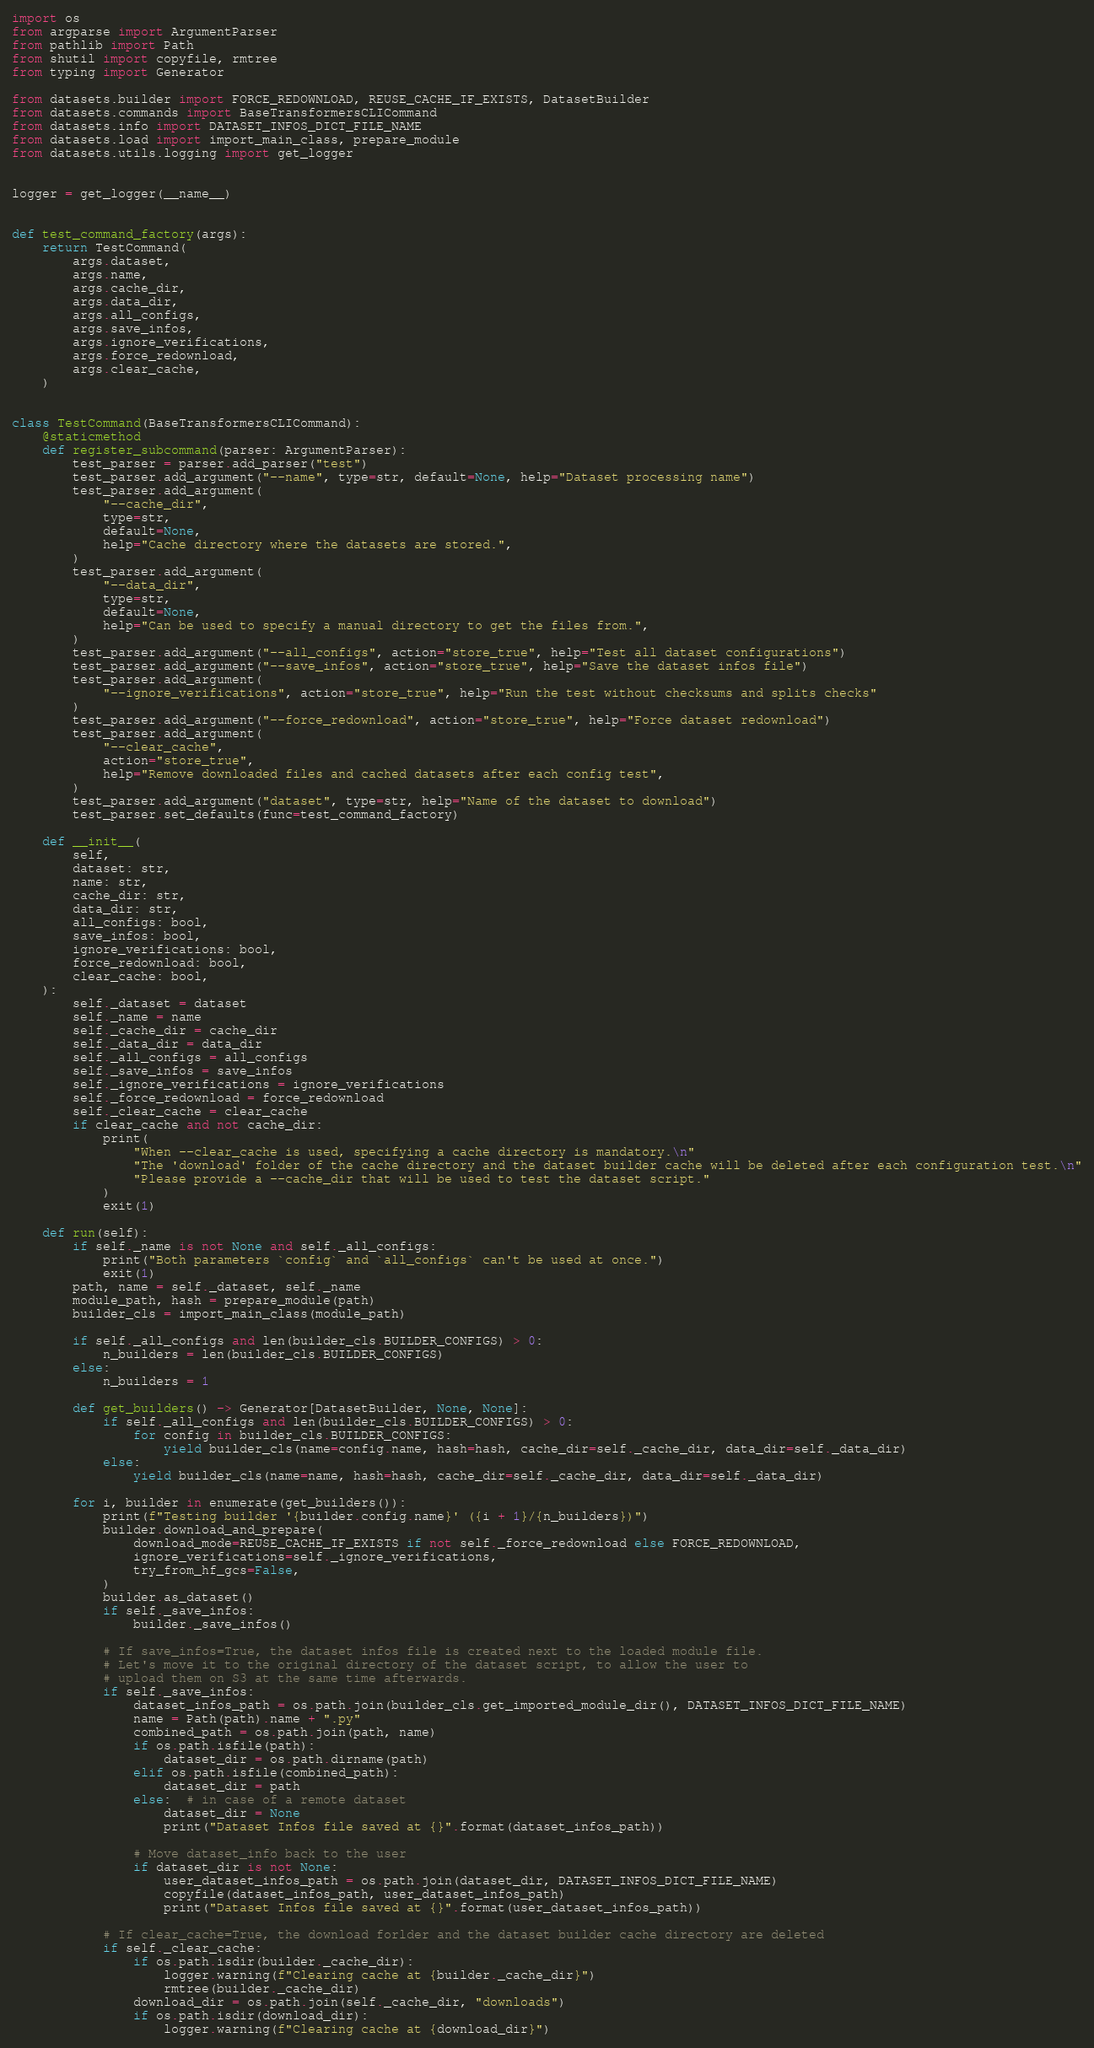Convert code to text. <code><loc_0><loc_0><loc_500><loc_500><_Python_>import os
from argparse import ArgumentParser
from pathlib import Path
from shutil import copyfile, rmtree
from typing import Generator

from datasets.builder import FORCE_REDOWNLOAD, REUSE_CACHE_IF_EXISTS, DatasetBuilder
from datasets.commands import BaseTransformersCLICommand
from datasets.info import DATASET_INFOS_DICT_FILE_NAME
from datasets.load import import_main_class, prepare_module
from datasets.utils.logging import get_logger


logger = get_logger(__name__)


def test_command_factory(args):
    return TestCommand(
        args.dataset,
        args.name,
        args.cache_dir,
        args.data_dir,
        args.all_configs,
        args.save_infos,
        args.ignore_verifications,
        args.force_redownload,
        args.clear_cache,
    )


class TestCommand(BaseTransformersCLICommand):
    @staticmethod
    def register_subcommand(parser: ArgumentParser):
        test_parser = parser.add_parser("test")
        test_parser.add_argument("--name", type=str, default=None, help="Dataset processing name")
        test_parser.add_argument(
            "--cache_dir",
            type=str,
            default=None,
            help="Cache directory where the datasets are stored.",
        )
        test_parser.add_argument(
            "--data_dir",
            type=str,
            default=None,
            help="Can be used to specify a manual directory to get the files from.",
        )
        test_parser.add_argument("--all_configs", action="store_true", help="Test all dataset configurations")
        test_parser.add_argument("--save_infos", action="store_true", help="Save the dataset infos file")
        test_parser.add_argument(
            "--ignore_verifications", action="store_true", help="Run the test without checksums and splits checks"
        )
        test_parser.add_argument("--force_redownload", action="store_true", help="Force dataset redownload")
        test_parser.add_argument(
            "--clear_cache",
            action="store_true",
            help="Remove downloaded files and cached datasets after each config test",
        )
        test_parser.add_argument("dataset", type=str, help="Name of the dataset to download")
        test_parser.set_defaults(func=test_command_factory)

    def __init__(
        self,
        dataset: str,
        name: str,
        cache_dir: str,
        data_dir: str,
        all_configs: bool,
        save_infos: bool,
        ignore_verifications: bool,
        force_redownload: bool,
        clear_cache: bool,
    ):
        self._dataset = dataset
        self._name = name
        self._cache_dir = cache_dir
        self._data_dir = data_dir
        self._all_configs = all_configs
        self._save_infos = save_infos
        self._ignore_verifications = ignore_verifications
        self._force_redownload = force_redownload
        self._clear_cache = clear_cache
        if clear_cache and not cache_dir:
            print(
                "When --clear_cache is used, specifying a cache directory is mandatory.\n"
                "The 'download' folder of the cache directory and the dataset builder cache will be deleted after each configuration test.\n"
                "Please provide a --cache_dir that will be used to test the dataset script."
            )
            exit(1)

    def run(self):
        if self._name is not None and self._all_configs:
            print("Both parameters `config` and `all_configs` can't be used at once.")
            exit(1)
        path, name = self._dataset, self._name
        module_path, hash = prepare_module(path)
        builder_cls = import_main_class(module_path)

        if self._all_configs and len(builder_cls.BUILDER_CONFIGS) > 0:
            n_builders = len(builder_cls.BUILDER_CONFIGS)
        else:
            n_builders = 1

        def get_builders() -> Generator[DatasetBuilder, None, None]:
            if self._all_configs and len(builder_cls.BUILDER_CONFIGS) > 0:
                for config in builder_cls.BUILDER_CONFIGS:
                    yield builder_cls(name=config.name, hash=hash, cache_dir=self._cache_dir, data_dir=self._data_dir)
            else:
                yield builder_cls(name=name, hash=hash, cache_dir=self._cache_dir, data_dir=self._data_dir)

        for i, builder in enumerate(get_builders()):
            print(f"Testing builder '{builder.config.name}' ({i + 1}/{n_builders})")
            builder.download_and_prepare(
                download_mode=REUSE_CACHE_IF_EXISTS if not self._force_redownload else FORCE_REDOWNLOAD,
                ignore_verifications=self._ignore_verifications,
                try_from_hf_gcs=False,
            )
            builder.as_dataset()
            if self._save_infos:
                builder._save_infos()

            # If save_infos=True, the dataset infos file is created next to the loaded module file.
            # Let's move it to the original directory of the dataset script, to allow the user to
            # upload them on S3 at the same time afterwards.
            if self._save_infos:
                dataset_infos_path = os.path.join(builder_cls.get_imported_module_dir(), DATASET_INFOS_DICT_FILE_NAME)
                name = Path(path).name + ".py"
                combined_path = os.path.join(path, name)
                if os.path.isfile(path):
                    dataset_dir = os.path.dirname(path)
                elif os.path.isfile(combined_path):
                    dataset_dir = path
                else:  # in case of a remote dataset
                    dataset_dir = None
                    print("Dataset Infos file saved at {}".format(dataset_infos_path))

                # Move dataset_info back to the user
                if dataset_dir is not None:
                    user_dataset_infos_path = os.path.join(dataset_dir, DATASET_INFOS_DICT_FILE_NAME)
                    copyfile(dataset_infos_path, user_dataset_infos_path)
                    print("Dataset Infos file saved at {}".format(user_dataset_infos_path))

            # If clear_cache=True, the download forlder and the dataset builder cache directory are deleted
            if self._clear_cache:
                if os.path.isdir(builder._cache_dir):
                    logger.warning(f"Clearing cache at {builder._cache_dir}")
                    rmtree(builder._cache_dir)
                download_dir = os.path.join(self._cache_dir, "downloads")
                if os.path.isdir(download_dir):
                    logger.warning(f"Clearing cache at {download_dir}")</code> 